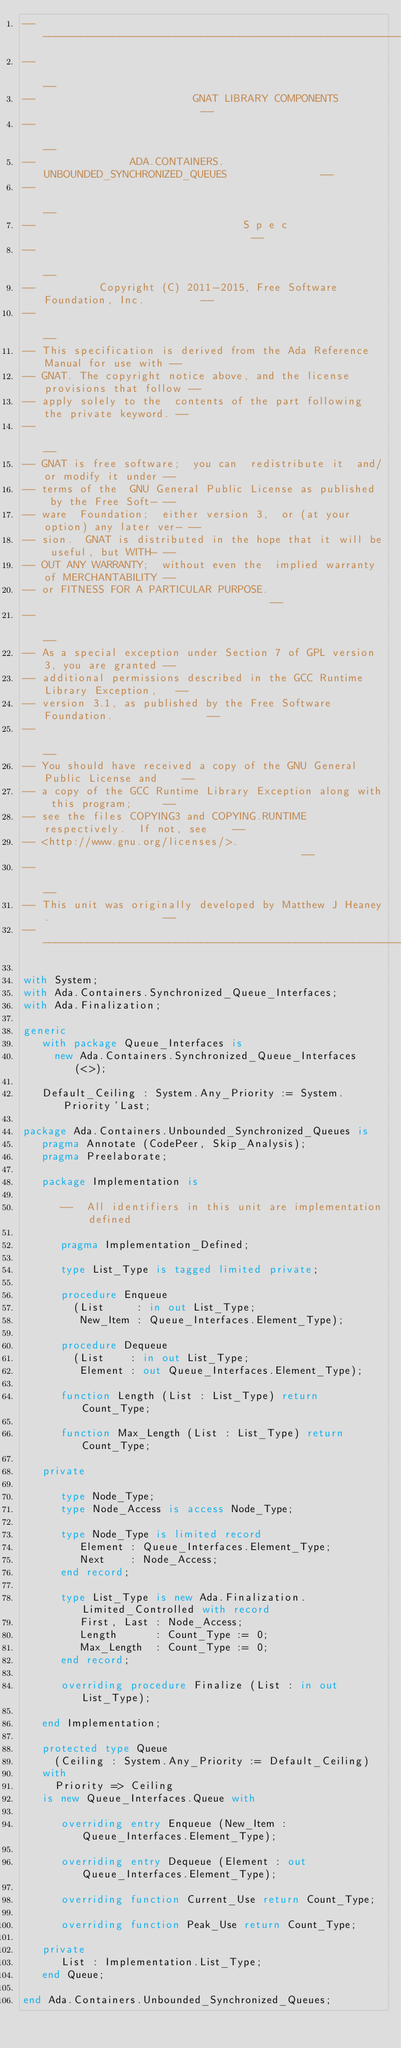<code> <loc_0><loc_0><loc_500><loc_500><_Ada_>------------------------------------------------------------------------------
--                                                                          --
--                         GNAT LIBRARY COMPONENTS                          --
--                                                                          --
--               ADA.CONTAINERS.UNBOUNDED_SYNCHRONIZED_QUEUES               --
--                                                                          --
--                                 S p e c                                  --
--                                                                          --
--          Copyright (C) 2011-2015, Free Software Foundation, Inc.         --
--                                                                          --
-- This specification is derived from the Ada Reference Manual for use with --
-- GNAT. The copyright notice above, and the license provisions that follow --
-- apply solely to the  contents of the part following the private keyword. --
--                                                                          --
-- GNAT is free software;  you can  redistribute it  and/or modify it under --
-- terms of the  GNU General Public License as published  by the Free Soft- --
-- ware  Foundation;  either version 3,  or (at your option) any later ver- --
-- sion.  GNAT is distributed in the hope that it will be useful, but WITH- --
-- OUT ANY WARRANTY;  without even the  implied warranty of MERCHANTABILITY --
-- or FITNESS FOR A PARTICULAR PURPOSE.                                     --
--                                                                          --
-- As a special exception under Section 7 of GPL version 3, you are granted --
-- additional permissions described in the GCC Runtime Library Exception,   --
-- version 3.1, as published by the Free Software Foundation.               --
--                                                                          --
-- You should have received a copy of the GNU General Public License and    --
-- a copy of the GCC Runtime Library Exception along with this program;     --
-- see the files COPYING3 and COPYING.RUNTIME respectively.  If not, see    --
-- <http://www.gnu.org/licenses/>.                                          --
--                                                                          --
-- This unit was originally developed by Matthew J Heaney.                  --
------------------------------------------------------------------------------

with System;
with Ada.Containers.Synchronized_Queue_Interfaces;
with Ada.Finalization;

generic
   with package Queue_Interfaces is
     new Ada.Containers.Synchronized_Queue_Interfaces (<>);

   Default_Ceiling : System.Any_Priority := System.Priority'Last;

package Ada.Containers.Unbounded_Synchronized_Queues is
   pragma Annotate (CodePeer, Skip_Analysis);
   pragma Preelaborate;

   package Implementation is

      --  All identifiers in this unit are implementation defined

      pragma Implementation_Defined;

      type List_Type is tagged limited private;

      procedure Enqueue
        (List     : in out List_Type;
         New_Item : Queue_Interfaces.Element_Type);

      procedure Dequeue
        (List    : in out List_Type;
         Element : out Queue_Interfaces.Element_Type);

      function Length (List : List_Type) return Count_Type;

      function Max_Length (List : List_Type) return Count_Type;

   private

      type Node_Type;
      type Node_Access is access Node_Type;

      type Node_Type is limited record
         Element : Queue_Interfaces.Element_Type;
         Next    : Node_Access;
      end record;

      type List_Type is new Ada.Finalization.Limited_Controlled with record
         First, Last : Node_Access;
         Length      : Count_Type := 0;
         Max_Length  : Count_Type := 0;
      end record;

      overriding procedure Finalize (List : in out List_Type);

   end Implementation;

   protected type Queue
     (Ceiling : System.Any_Priority := Default_Ceiling)
   with
     Priority => Ceiling
   is new Queue_Interfaces.Queue with

      overriding entry Enqueue (New_Item : Queue_Interfaces.Element_Type);

      overriding entry Dequeue (Element : out Queue_Interfaces.Element_Type);

      overriding function Current_Use return Count_Type;

      overriding function Peak_Use return Count_Type;

   private
      List : Implementation.List_Type;
   end Queue;

end Ada.Containers.Unbounded_Synchronized_Queues;
</code> 